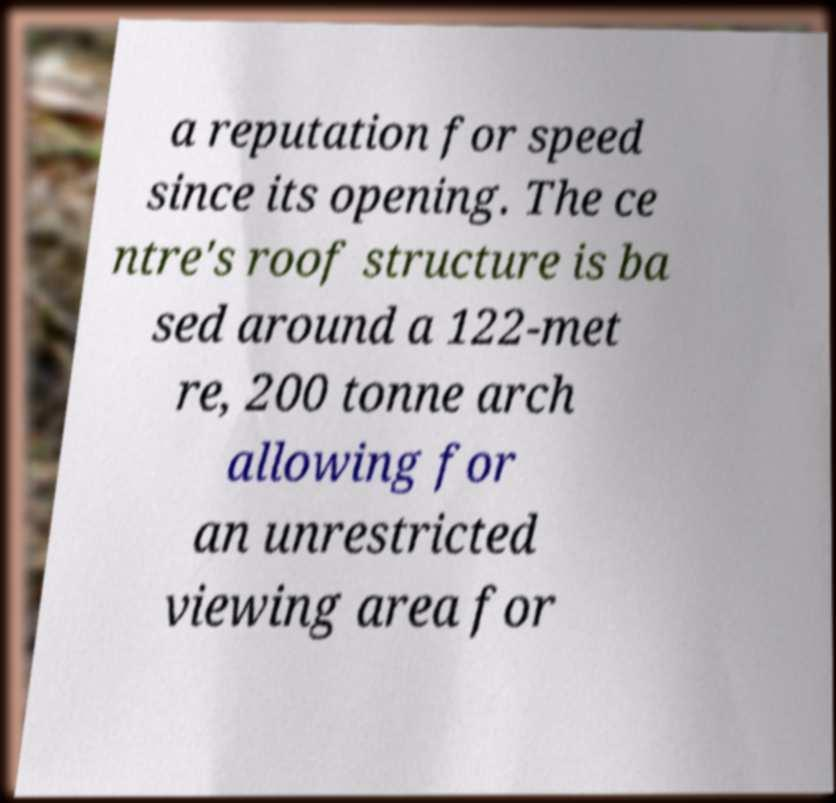Could you extract and type out the text from this image? a reputation for speed since its opening. The ce ntre's roof structure is ba sed around a 122-met re, 200 tonne arch allowing for an unrestricted viewing area for 